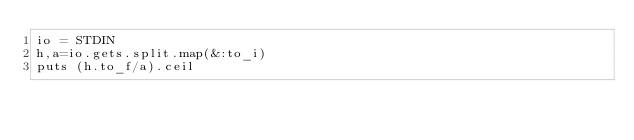Convert code to text. <code><loc_0><loc_0><loc_500><loc_500><_Ruby_>io = STDIN
h,a=io.gets.split.map(&:to_i)
puts (h.to_f/a).ceil
</code> 